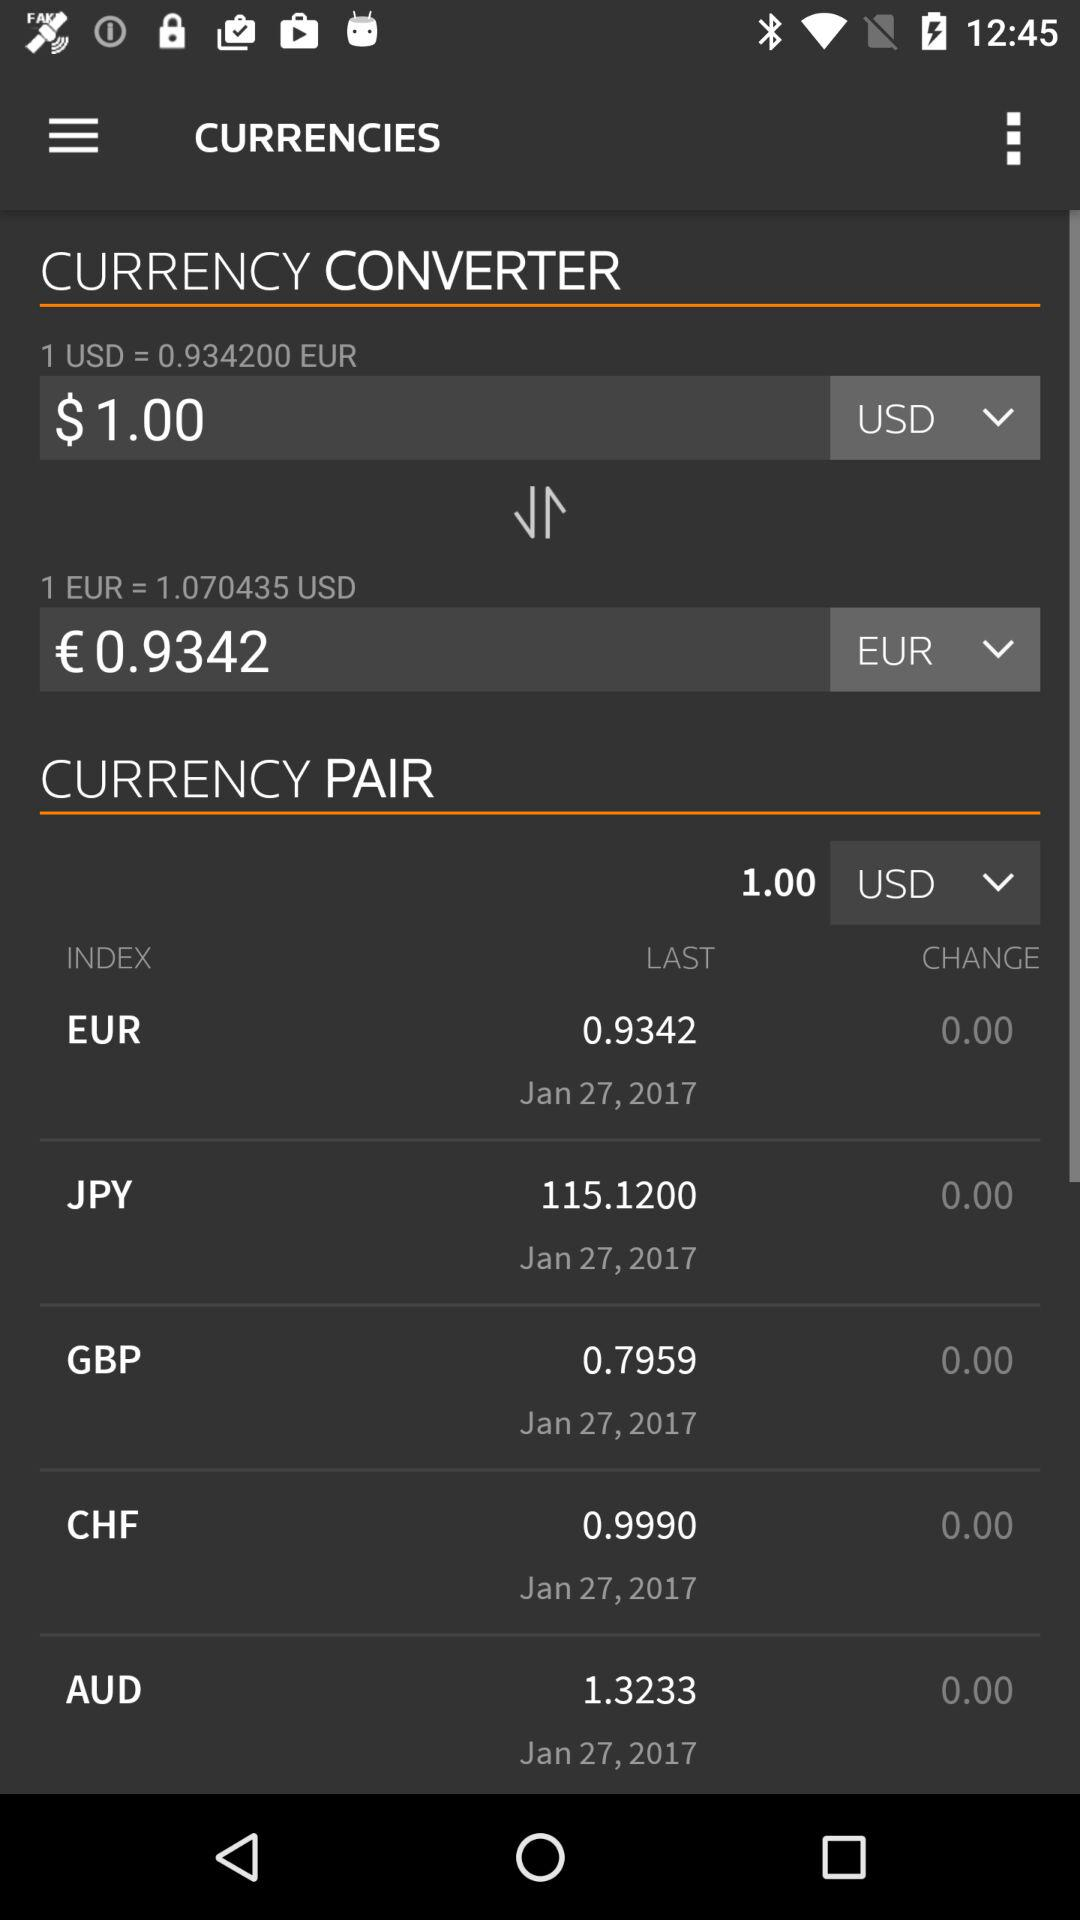How much is 1 USD worth in EUR?
Answer the question using a single word or phrase. 0.9342 